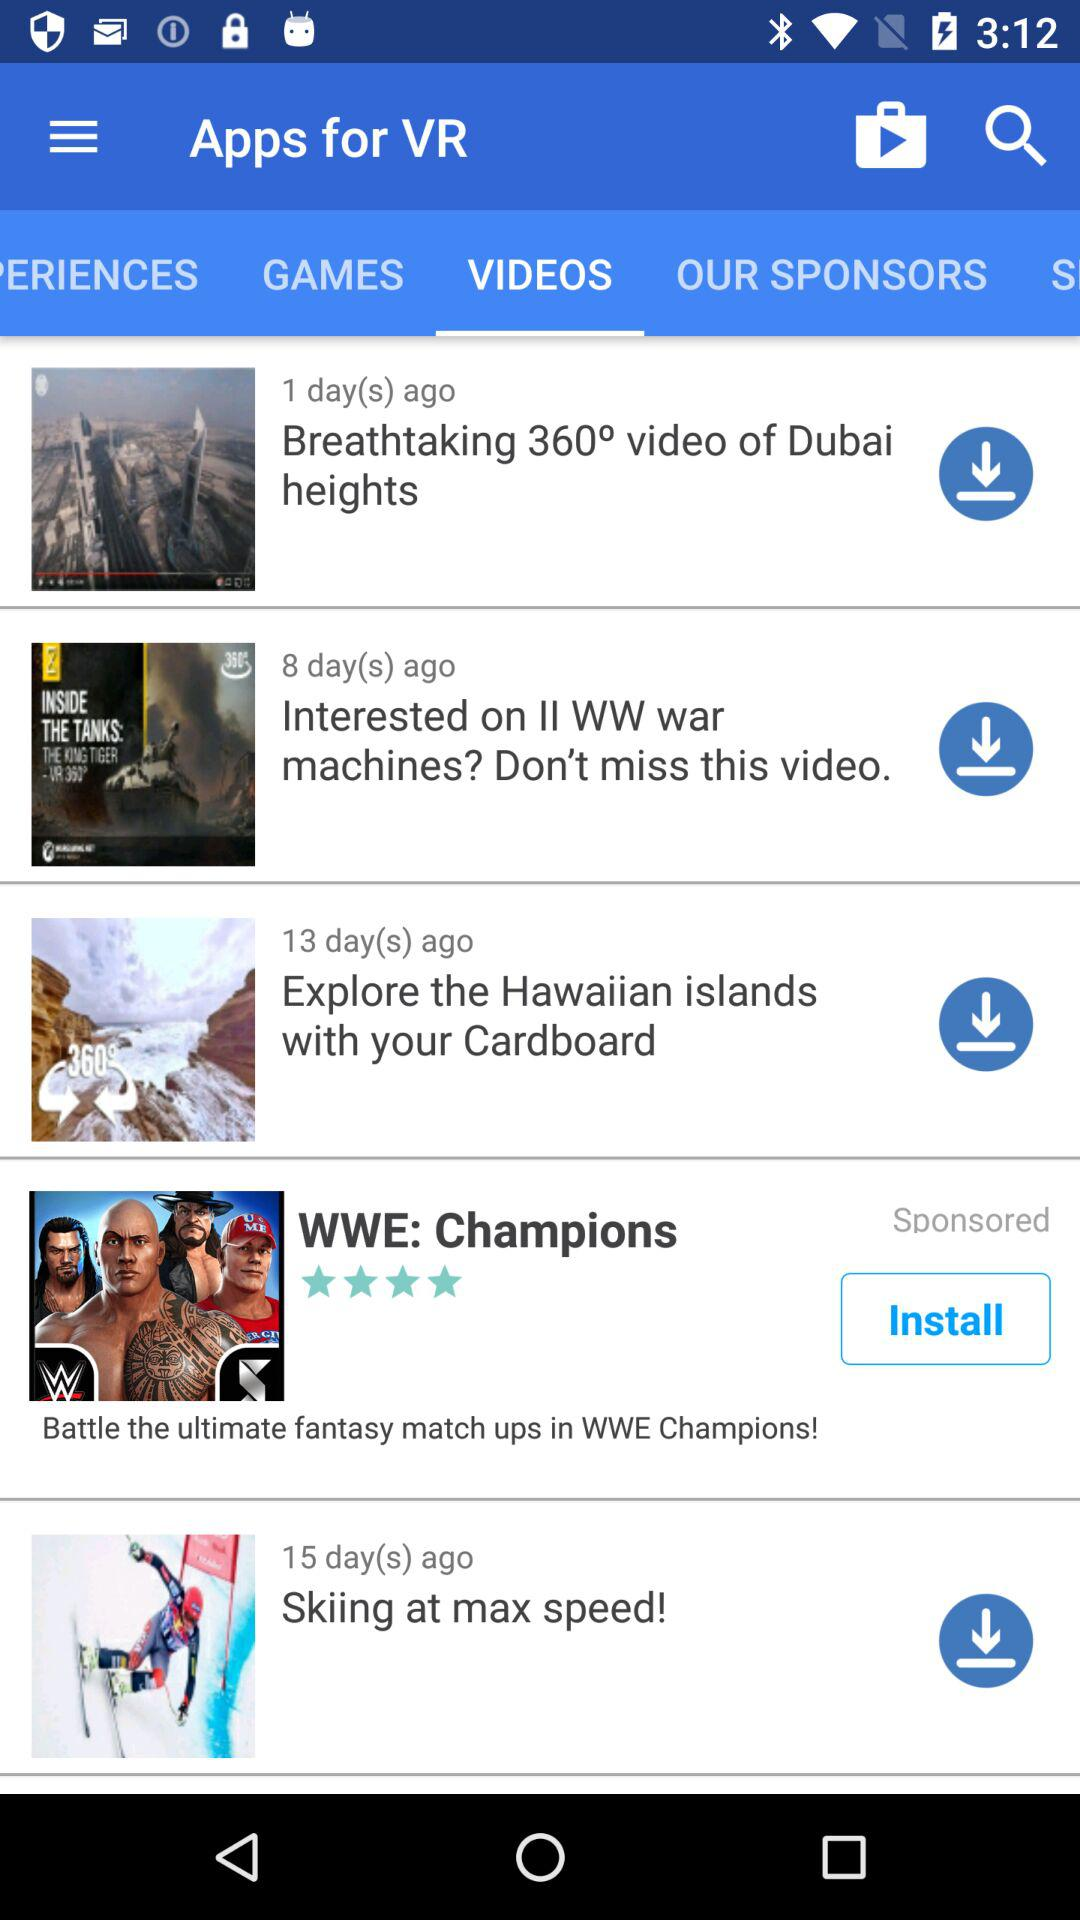On which tab of the application are we? You are on the "VIDEOS" tab of the application. 